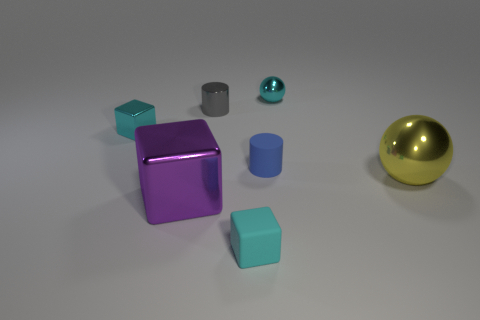Subtract all gray spheres. Subtract all green blocks. How many spheres are left? 2 Add 2 small things. How many objects exist? 9 Subtract all cubes. How many objects are left? 4 Subtract 0 purple cylinders. How many objects are left? 7 Subtract all yellow metal objects. Subtract all cylinders. How many objects are left? 4 Add 3 cyan balls. How many cyan balls are left? 4 Add 7 balls. How many balls exist? 9 